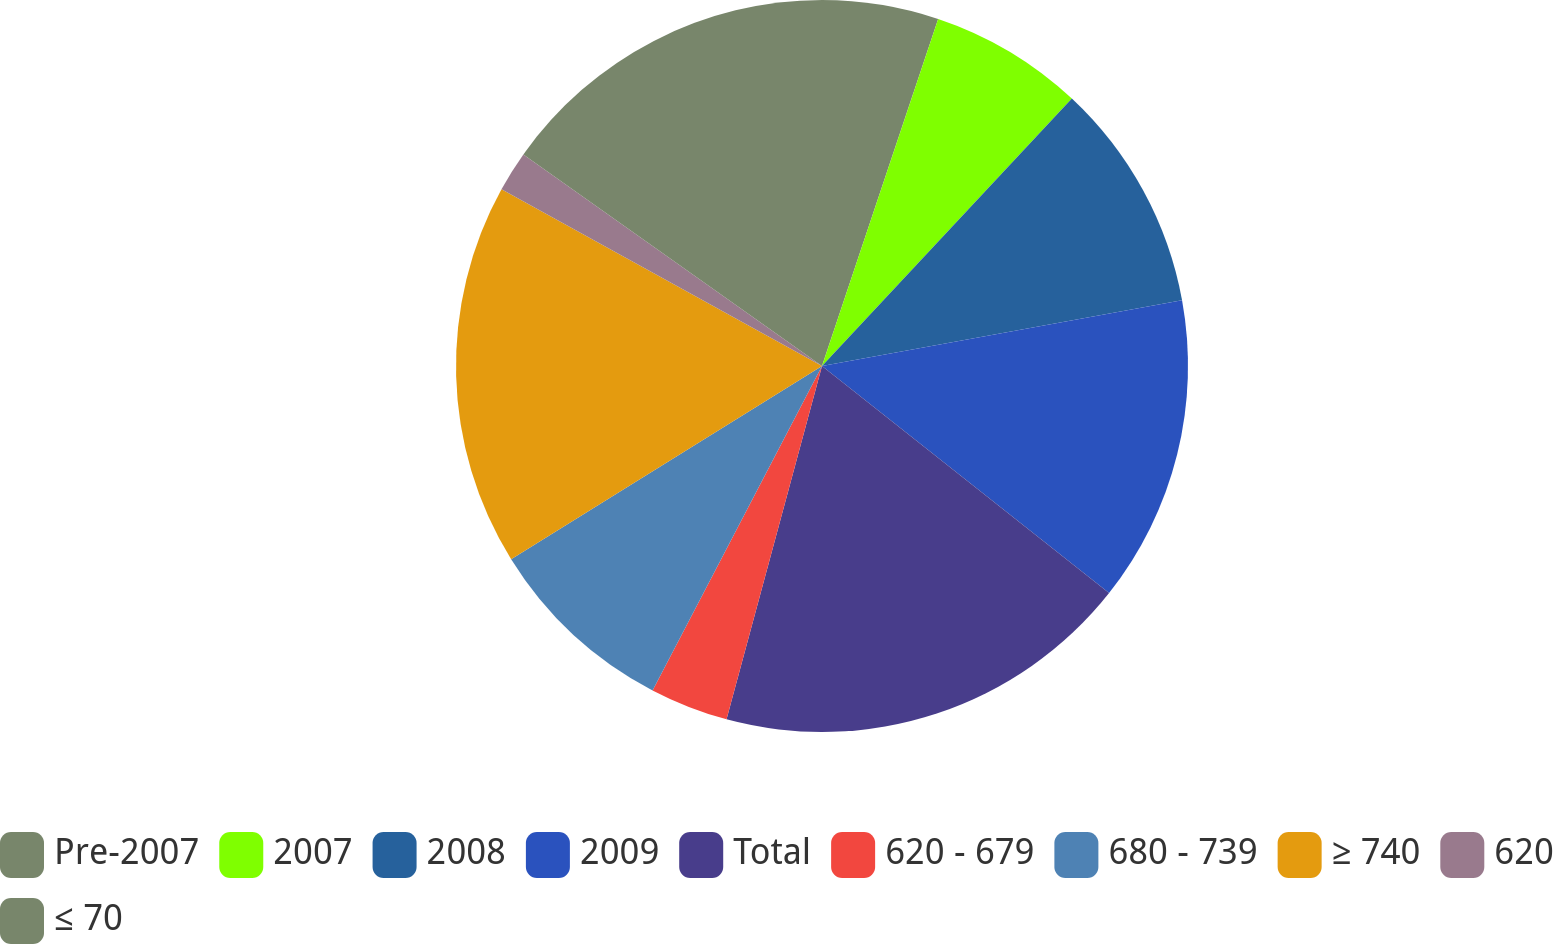Convert chart. <chart><loc_0><loc_0><loc_500><loc_500><pie_chart><fcel>Pre-2007<fcel>2007<fcel>2008<fcel>2009<fcel>Total<fcel>620 - 679<fcel>680 - 739<fcel>≥ 740<fcel>620<fcel>≤ 70<nl><fcel>5.14%<fcel>6.82%<fcel>10.17%<fcel>13.52%<fcel>18.55%<fcel>3.46%<fcel>8.49%<fcel>16.87%<fcel>1.79%<fcel>15.19%<nl></chart> 